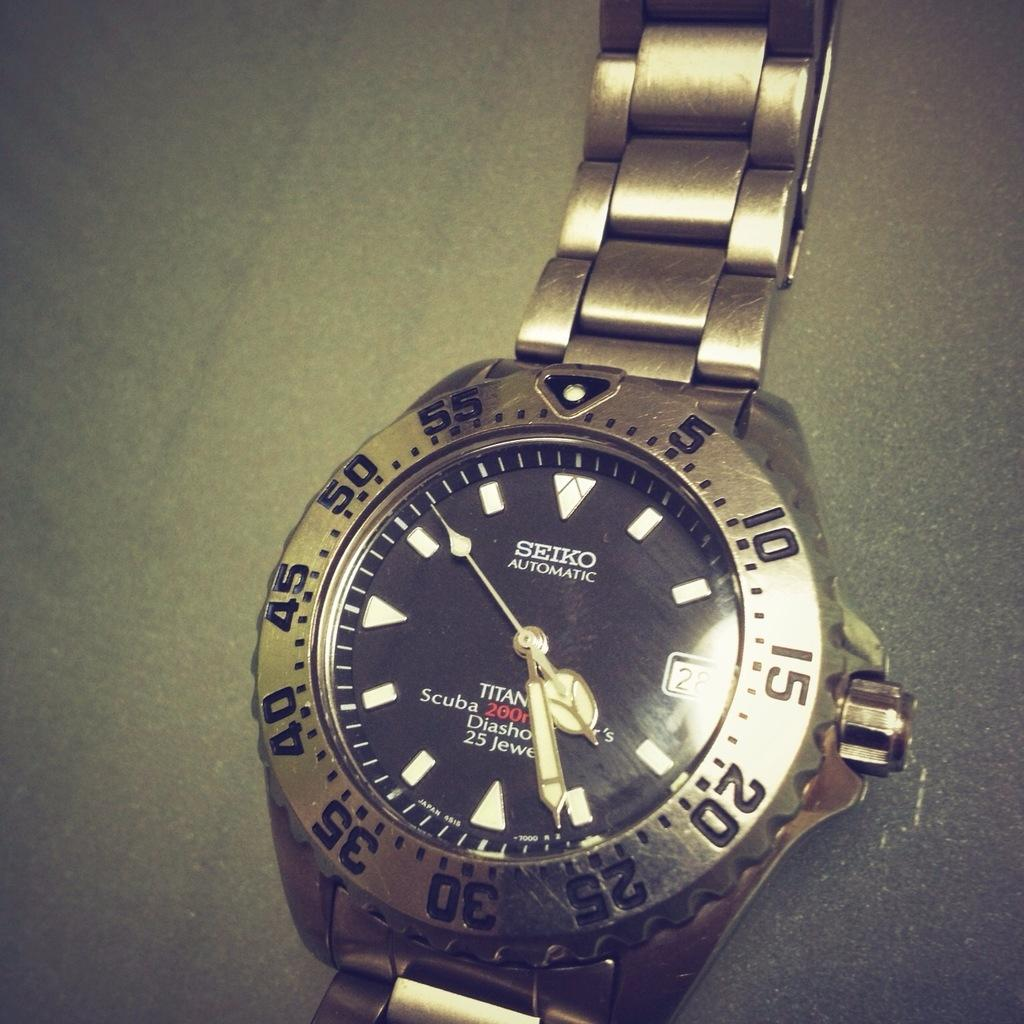<image>
Summarize the visual content of the image. an image of a SEIKO automatic watch face. 